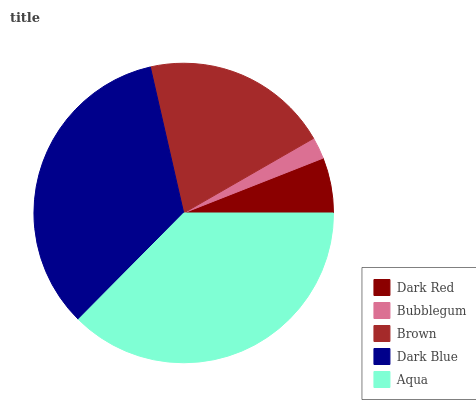Is Bubblegum the minimum?
Answer yes or no. Yes. Is Aqua the maximum?
Answer yes or no. Yes. Is Brown the minimum?
Answer yes or no. No. Is Brown the maximum?
Answer yes or no. No. Is Brown greater than Bubblegum?
Answer yes or no. Yes. Is Bubblegum less than Brown?
Answer yes or no. Yes. Is Bubblegum greater than Brown?
Answer yes or no. No. Is Brown less than Bubblegum?
Answer yes or no. No. Is Brown the high median?
Answer yes or no. Yes. Is Brown the low median?
Answer yes or no. Yes. Is Dark Blue the high median?
Answer yes or no. No. Is Bubblegum the low median?
Answer yes or no. No. 